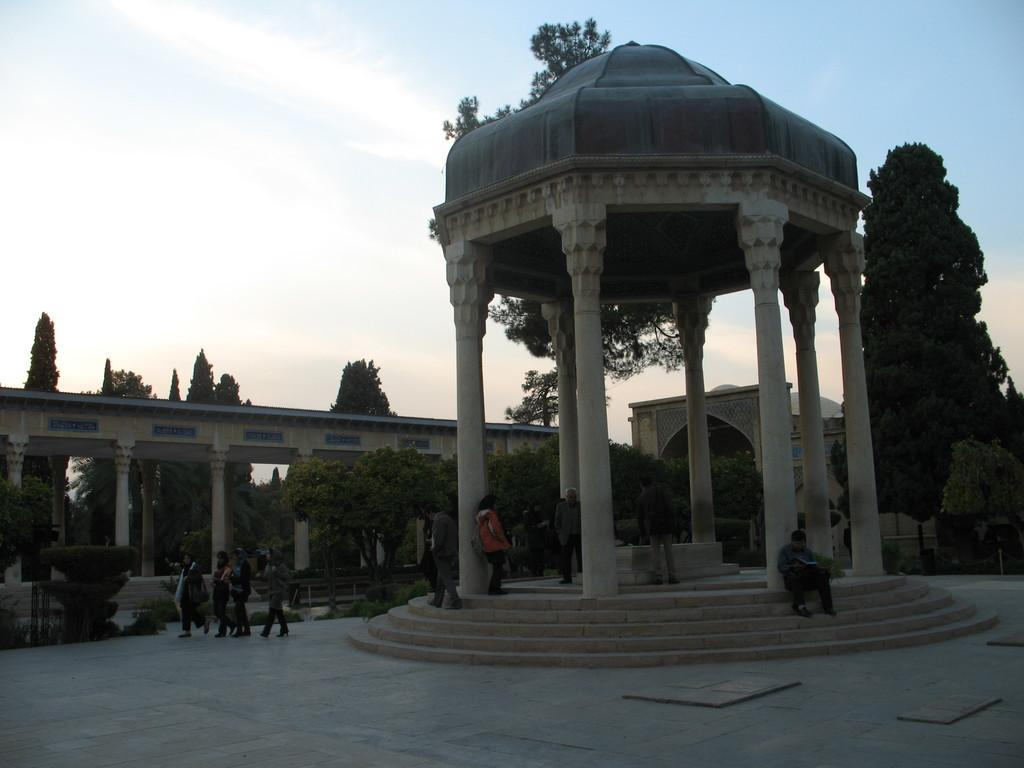How many people are in the image? There is a group of people in the image, but the exact number is not specified. What can be seen in the background of the image? There are trees, clouds, and a building in the background of the image. What type of sign can be seen on the farm in the image? There is no sign or farm present in the image. What advice can be given to the people in the image? We cannot give advice to the people in the image, as we do not know their situation or context. 